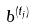<formula> <loc_0><loc_0><loc_500><loc_500>b ^ { ( t _ { j } ) }</formula> 